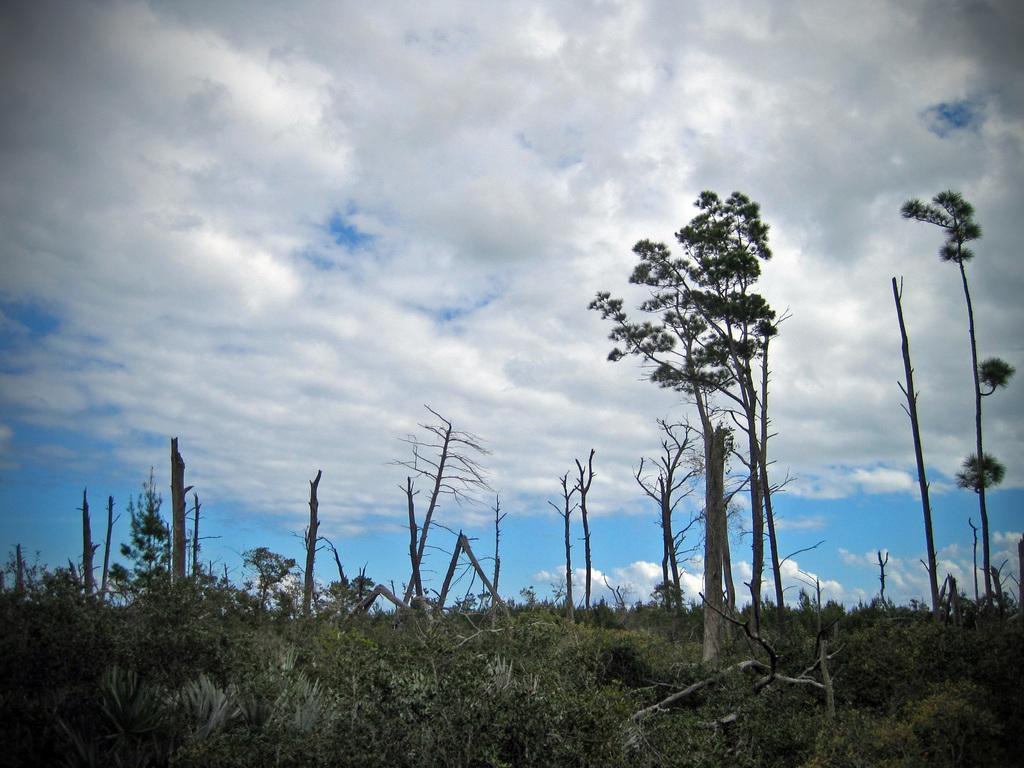What type of vegetation can be seen in the image? There is grass, plants, and trees visible in the image. What else can be found in the image besides vegetation? There are sticks in the image. What is visible at the top of the image? The sky is visible at the top of the image. How many crayons are being used by the babies in the image? There are no crayons or babies present in the image. Is there a volcano erupting in the image? There is no volcano present in the image. 